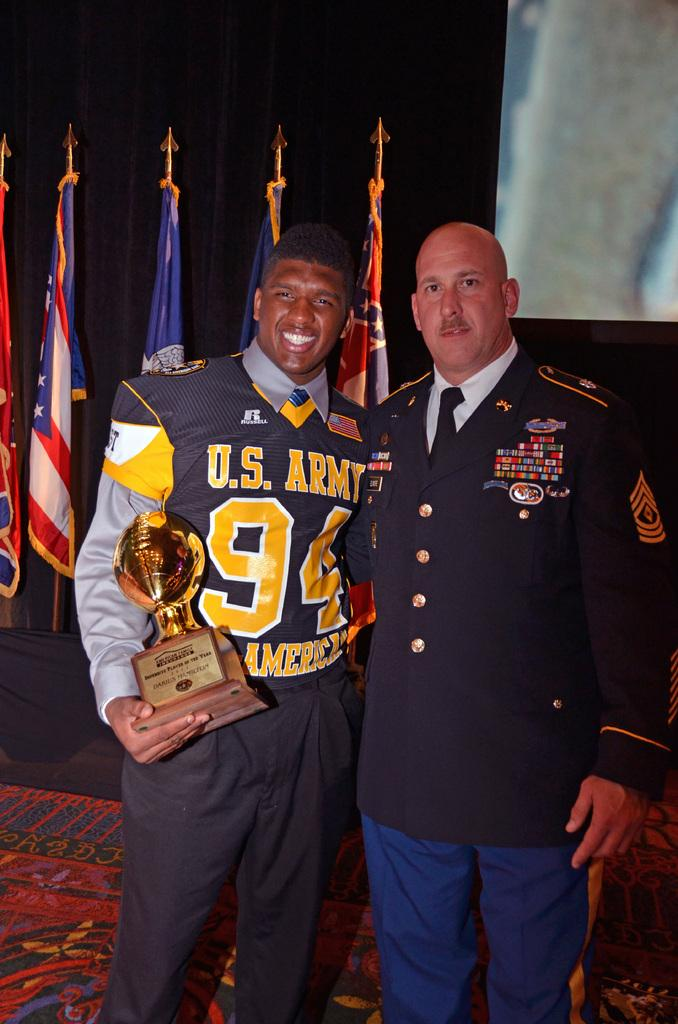<image>
Share a concise interpretation of the image provided. A person wearing a jersey that says U.S. Army is standing with a man in uniform. 